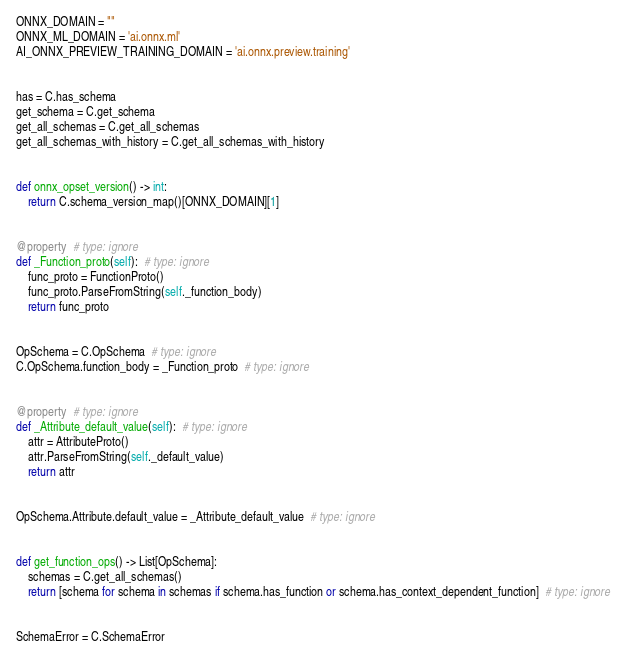Convert code to text. <code><loc_0><loc_0><loc_500><loc_500><_Python_>ONNX_DOMAIN = ""
ONNX_ML_DOMAIN = 'ai.onnx.ml'
AI_ONNX_PREVIEW_TRAINING_DOMAIN = 'ai.onnx.preview.training'


has = C.has_schema
get_schema = C.get_schema
get_all_schemas = C.get_all_schemas
get_all_schemas_with_history = C.get_all_schemas_with_history


def onnx_opset_version() -> int:
    return C.schema_version_map()[ONNX_DOMAIN][1]


@property  # type: ignore
def _Function_proto(self):  # type: ignore
    func_proto = FunctionProto()
    func_proto.ParseFromString(self._function_body)
    return func_proto


OpSchema = C.OpSchema  # type: ignore
C.OpSchema.function_body = _Function_proto  # type: ignore


@property  # type: ignore
def _Attribute_default_value(self):  # type: ignore
    attr = AttributeProto()
    attr.ParseFromString(self._default_value)
    return attr


OpSchema.Attribute.default_value = _Attribute_default_value  # type: ignore


def get_function_ops() -> List[OpSchema]:
    schemas = C.get_all_schemas()
    return [schema for schema in schemas if schema.has_function or schema.has_context_dependent_function]  # type: ignore


SchemaError = C.SchemaError
</code> 